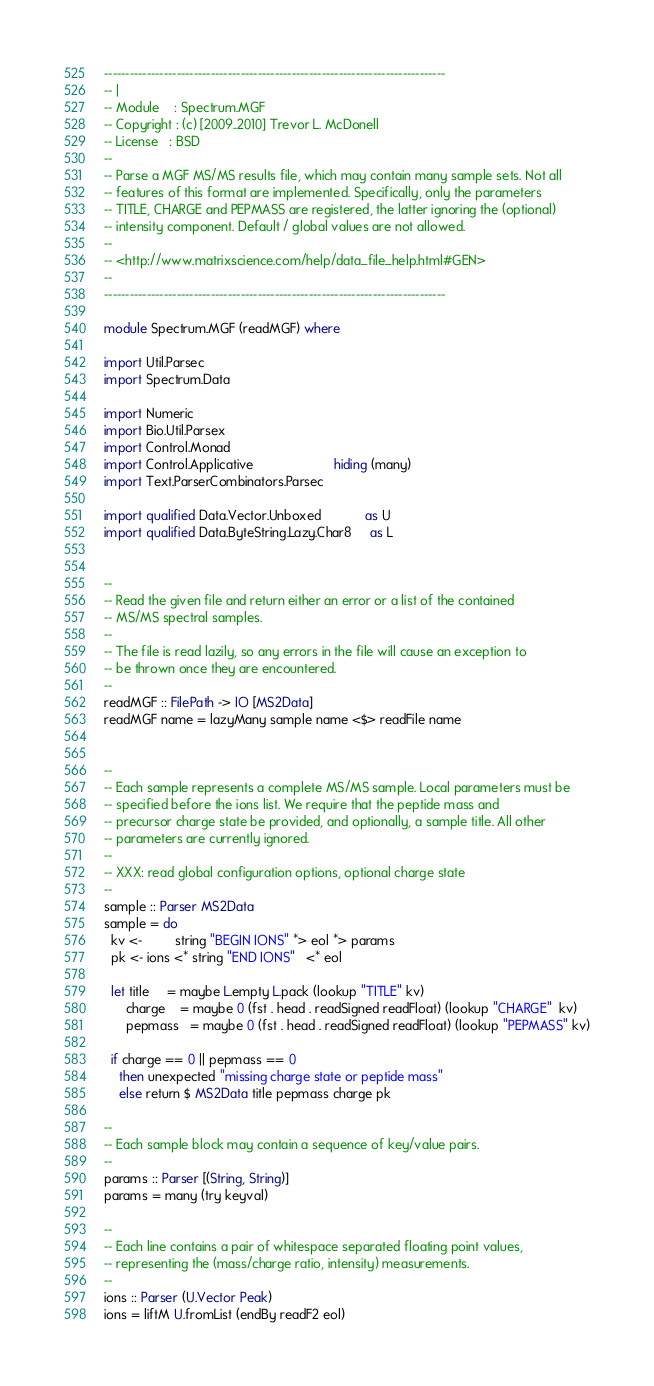Convert code to text. <code><loc_0><loc_0><loc_500><loc_500><_Haskell_>--------------------------------------------------------------------------------
-- |
-- Module    : Spectrum.MGF
-- Copyright : (c) [2009..2010] Trevor L. McDonell
-- License   : BSD
--
-- Parse a MGF MS/MS results file, which may contain many sample sets. Not all
-- features of this format are implemented. Specifically, only the parameters
-- TITLE, CHARGE and PEPMASS are registered, the latter ignoring the (optional)
-- intensity component. Default / global values are not allowed.
--
-- <http://www.matrixscience.com/help/data_file_help.html#GEN>
--
--------------------------------------------------------------------------------

module Spectrum.MGF (readMGF) where

import Util.Parsec
import Spectrum.Data

import Numeric
import Bio.Util.Parsex
import Control.Monad
import Control.Applicative                      hiding (many)
import Text.ParserCombinators.Parsec

import qualified Data.Vector.Unboxed            as U
import qualified Data.ByteString.Lazy.Char8     as L


--
-- Read the given file and return either an error or a list of the contained
-- MS/MS spectral samples.
--
-- The file is read lazily, so any errors in the file will cause an exception to
-- be thrown once they are encountered.
--
readMGF :: FilePath -> IO [MS2Data]
readMGF name = lazyMany sample name <$> readFile name


--
-- Each sample represents a complete MS/MS sample. Local parameters must be
-- specified before the ions list. We require that the peptide mass and
-- precursor charge state be provided, and optionally, a sample title. All other
-- parameters are currently ignored.
--
-- XXX: read global configuration options, optional charge state
--
sample :: Parser MS2Data
sample = do
  kv <-         string "BEGIN IONS" *> eol *> params
  pk <- ions <* string "END IONS"   <* eol

  let title     = maybe L.empty L.pack (lookup "TITLE" kv)
      charge    = maybe 0 (fst . head . readSigned readFloat) (lookup "CHARGE"  kv)
      pepmass   = maybe 0 (fst . head . readSigned readFloat) (lookup "PEPMASS" kv)

  if charge == 0 || pepmass == 0
    then unexpected "missing charge state or peptide mass"
    else return $ MS2Data title pepmass charge pk

--
-- Each sample block may contain a sequence of key/value pairs.
--
params :: Parser [(String, String)]
params = many (try keyval)

--
-- Each line contains a pair of whitespace separated floating point values,
-- representing the (mass/charge ratio, intensity) measurements.
--
ions :: Parser (U.Vector Peak)
ions = liftM U.fromList (endBy readF2 eol)

</code> 